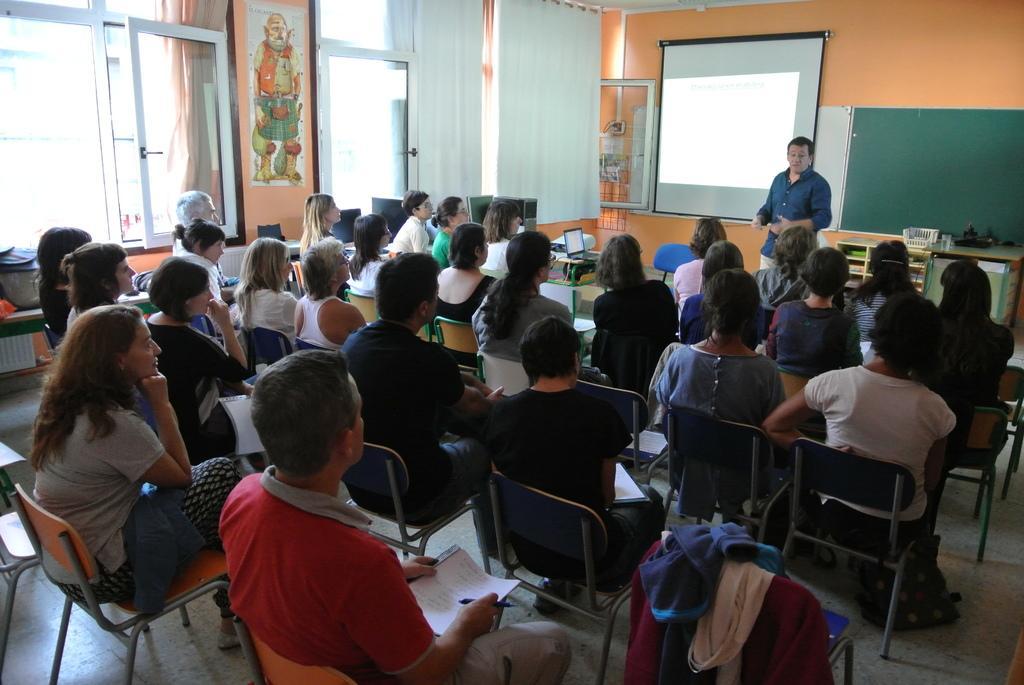How would you summarize this image in a sentence or two? This is an inside view of a room. Here I can see few people are sitting on the chairs facing towards the back side. In the background there is a man standing and speaking. At the back of this man there is a screen and a board are attached to the wall. Beside this man there is a table on which few objects are placed. At the top there are few curtains to the windows and also I can see a poster attached to the wall. 